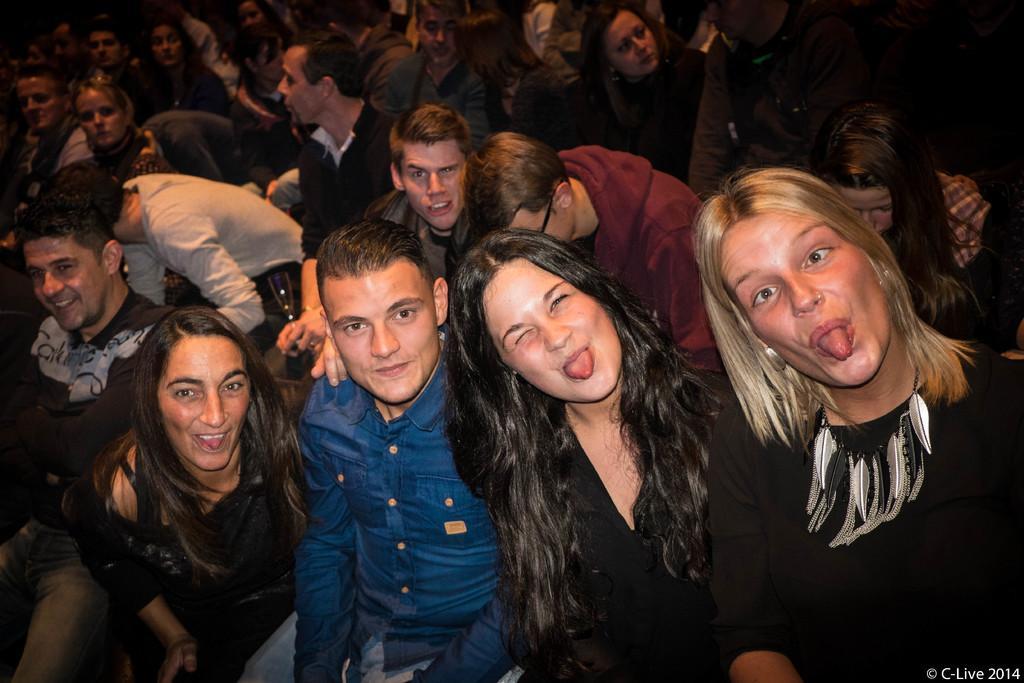Describe this image in one or two sentences. Here we can see a group of people and it is called as crowd. Infront we can see four persons posing to a camera. 